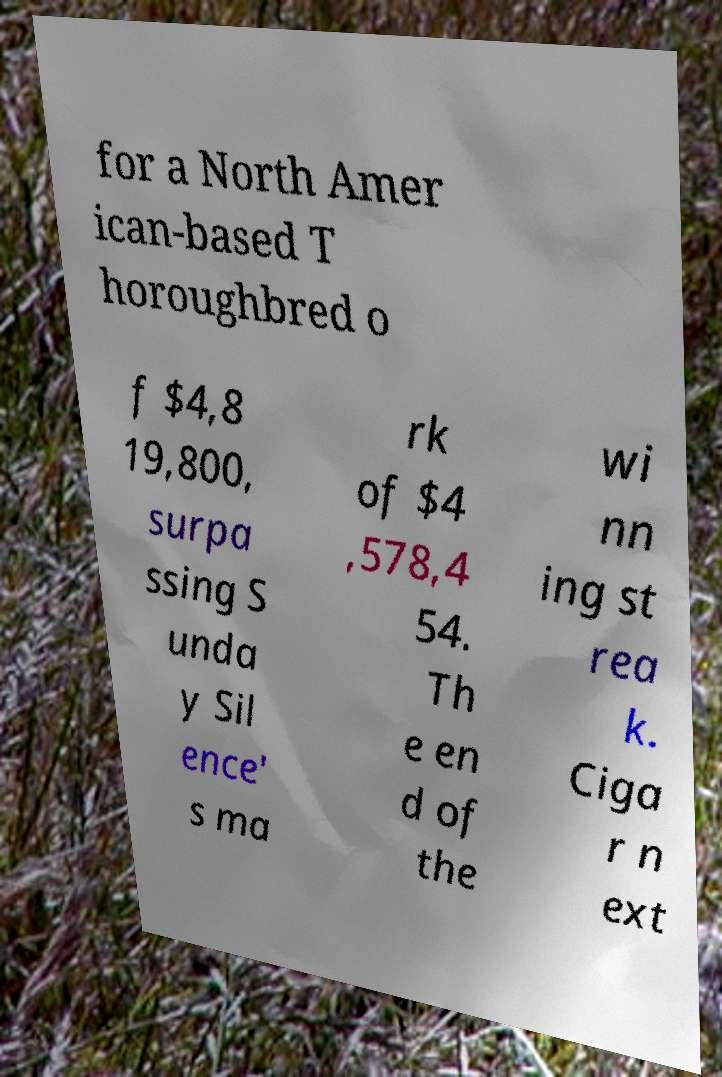Can you accurately transcribe the text from the provided image for me? for a North Amer ican-based T horoughbred o f $4,8 19,800, surpa ssing S unda y Sil ence' s ma rk of $4 ,578,4 54. Th e en d of the wi nn ing st rea k. Ciga r n ext 